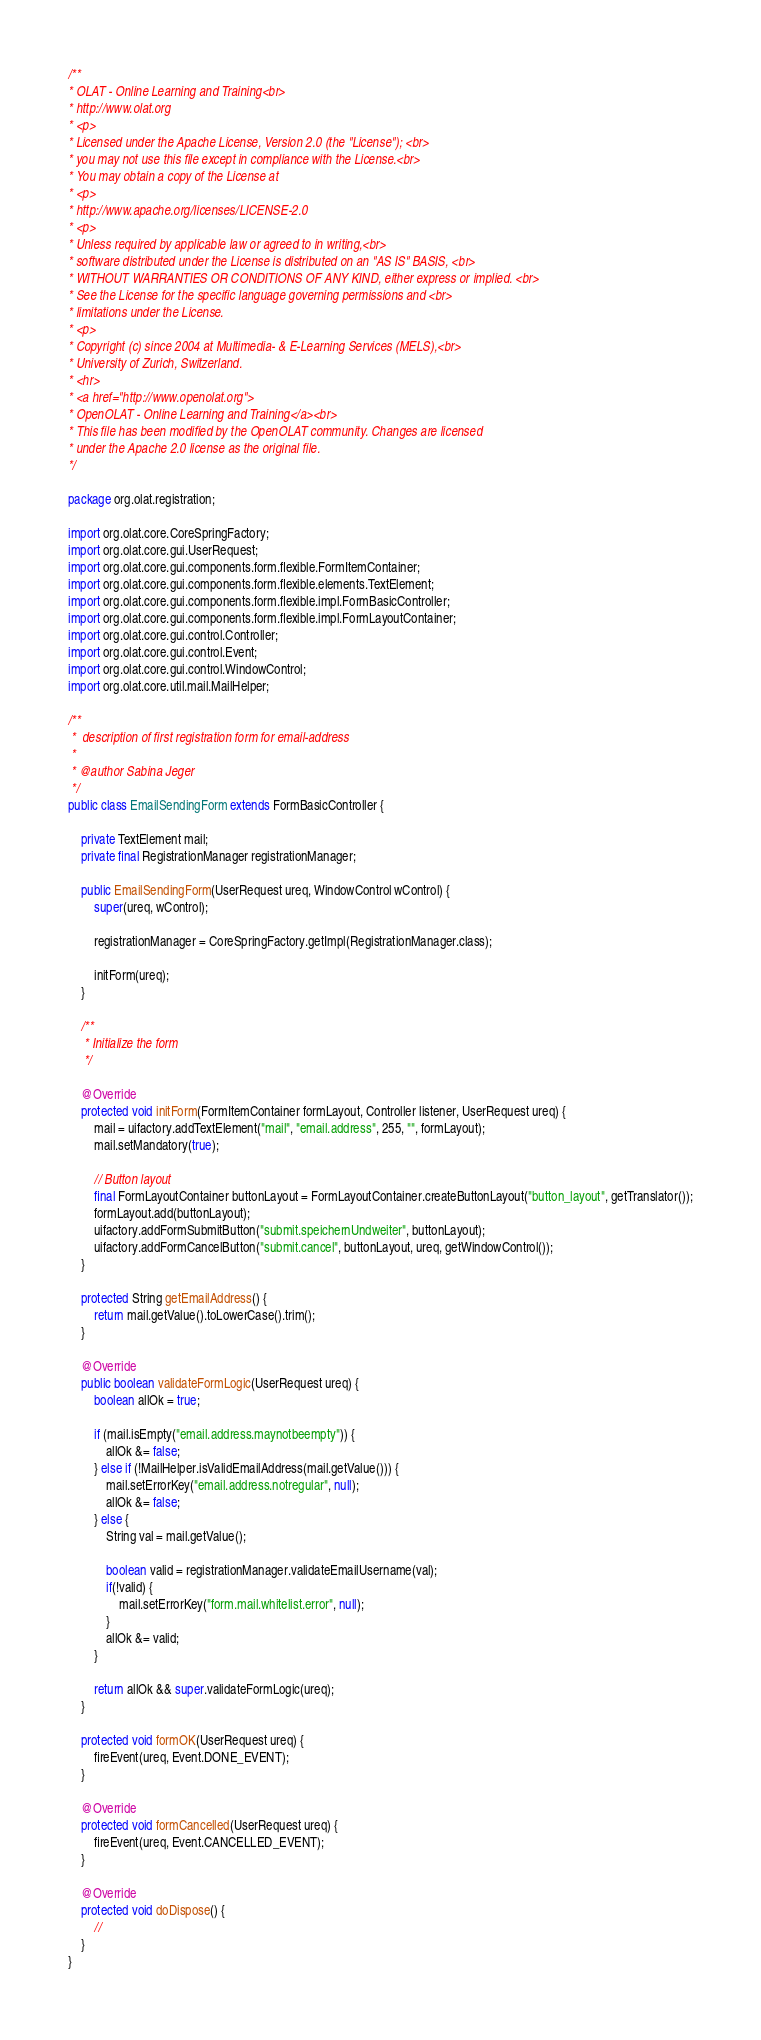Convert code to text. <code><loc_0><loc_0><loc_500><loc_500><_Java_>/**
* OLAT - Online Learning and Training<br>
* http://www.olat.org
* <p>
* Licensed under the Apache License, Version 2.0 (the "License"); <br>
* you may not use this file except in compliance with the License.<br>
* You may obtain a copy of the License at
* <p>
* http://www.apache.org/licenses/LICENSE-2.0
* <p>
* Unless required by applicable law or agreed to in writing,<br>
* software distributed under the License is distributed on an "AS IS" BASIS, <br>
* WITHOUT WARRANTIES OR CONDITIONS OF ANY KIND, either express or implied. <br>
* See the License for the specific language governing permissions and <br>
* limitations under the License.
* <p>
* Copyright (c) since 2004 at Multimedia- & E-Learning Services (MELS),<br>
* University of Zurich, Switzerland.
* <hr>
* <a href="http://www.openolat.org">
* OpenOLAT - Online Learning and Training</a><br>
* This file has been modified by the OpenOLAT community. Changes are licensed
* under the Apache 2.0 license as the original file.
*/

package org.olat.registration;

import org.olat.core.CoreSpringFactory;
import org.olat.core.gui.UserRequest;
import org.olat.core.gui.components.form.flexible.FormItemContainer;
import org.olat.core.gui.components.form.flexible.elements.TextElement;
import org.olat.core.gui.components.form.flexible.impl.FormBasicController;
import org.olat.core.gui.components.form.flexible.impl.FormLayoutContainer;
import org.olat.core.gui.control.Controller;
import org.olat.core.gui.control.Event;
import org.olat.core.gui.control.WindowControl;
import org.olat.core.util.mail.MailHelper;

/**
 *  description of first registration form for email-address
 * 
 * @author Sabina Jeger
 */
public class EmailSendingForm extends FormBasicController {
	
	private TextElement mail;
	private final RegistrationManager registrationManager;
	
	public EmailSendingForm(UserRequest ureq, WindowControl wControl) {
		super(ureq, wControl);
		
		registrationManager = CoreSpringFactory.getImpl(RegistrationManager.class);
		
		initForm(ureq);
	}

	/**
	 * Initialize the form
	 */
	
	@Override
	protected void initForm(FormItemContainer formLayout, Controller listener, UserRequest ureq) {
		mail = uifactory.addTextElement("mail", "email.address", 255, "", formLayout);
		mail.setMandatory(true);
		
		// Button layout
		final FormLayoutContainer buttonLayout = FormLayoutContainer.createButtonLayout("button_layout", getTranslator());
		formLayout.add(buttonLayout);
		uifactory.addFormSubmitButton("submit.speichernUndweiter", buttonLayout);
		uifactory.addFormCancelButton("submit.cancel", buttonLayout, ureq, getWindowControl());
	}

	protected String getEmailAddress() {
		return mail.getValue().toLowerCase().trim();
	}
	
	@Override
	public boolean validateFormLogic(UserRequest ureq) {
		boolean allOk = true;
		
		if (mail.isEmpty("email.address.maynotbeempty")) {
			allOk &= false;
		} else if (!MailHelper.isValidEmailAddress(mail.getValue())) {
			mail.setErrorKey("email.address.notregular", null);
			allOk &= false;
		} else {
			String val = mail.getValue();
			
			boolean valid = registrationManager.validateEmailUsername(val);
			if(!valid) {
				mail.setErrorKey("form.mail.whitelist.error", null);
			}
			allOk &= valid;
		}

		return allOk && super.validateFormLogic(ureq);
	}

	protected void formOK(UserRequest ureq) {
		fireEvent(ureq, Event.DONE_EVENT);
	}
	
	@Override
	protected void formCancelled(UserRequest ureq) {
		fireEvent(ureq, Event.CANCELLED_EVENT);
	}
	
	@Override
	protected void doDispose() {
		//
	}
}
</code> 